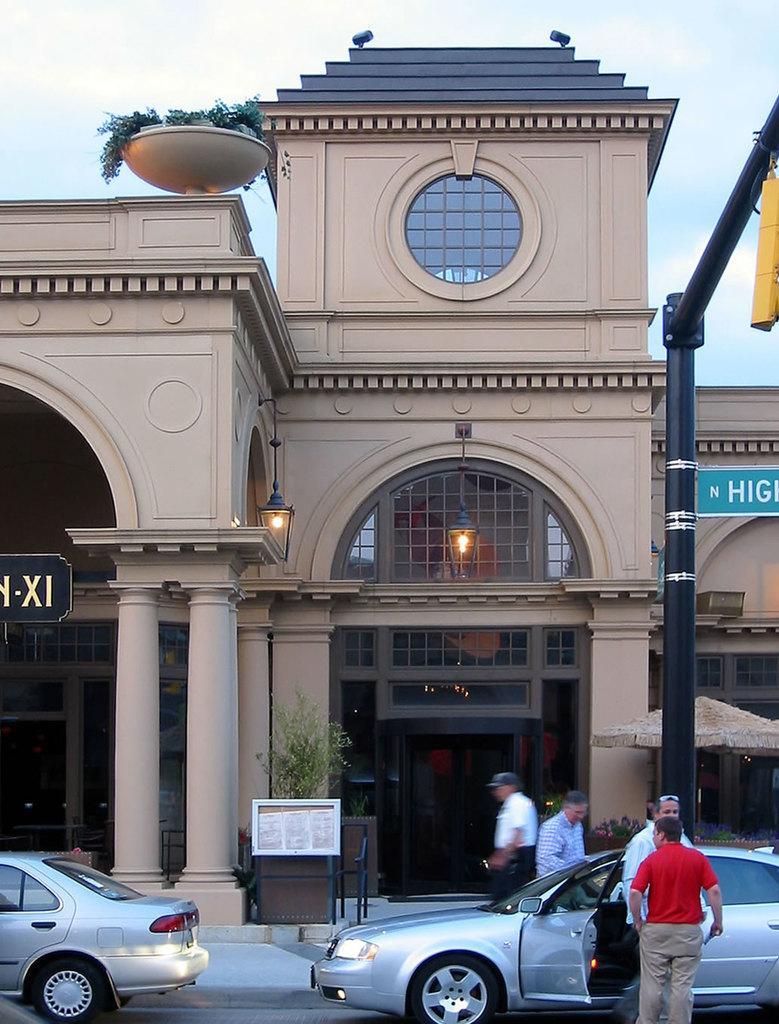Could you give a brief overview of what you see in this image? This picture is taken from outside of the building. In this image, on the right side, we can see two men are standing on the road. On the right side, we can also see a car and a pole which is in black color. On the left side, we can also see another car which is placed on the road. In the background, we can see two men, board, plants, pillars, building, glass window. At the top, we can see a sky. 